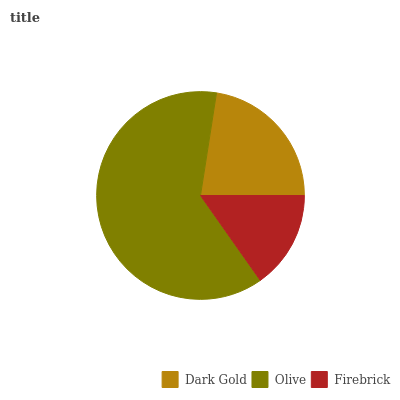Is Firebrick the minimum?
Answer yes or no. Yes. Is Olive the maximum?
Answer yes or no. Yes. Is Olive the minimum?
Answer yes or no. No. Is Firebrick the maximum?
Answer yes or no. No. Is Olive greater than Firebrick?
Answer yes or no. Yes. Is Firebrick less than Olive?
Answer yes or no. Yes. Is Firebrick greater than Olive?
Answer yes or no. No. Is Olive less than Firebrick?
Answer yes or no. No. Is Dark Gold the high median?
Answer yes or no. Yes. Is Dark Gold the low median?
Answer yes or no. Yes. Is Firebrick the high median?
Answer yes or no. No. Is Olive the low median?
Answer yes or no. No. 